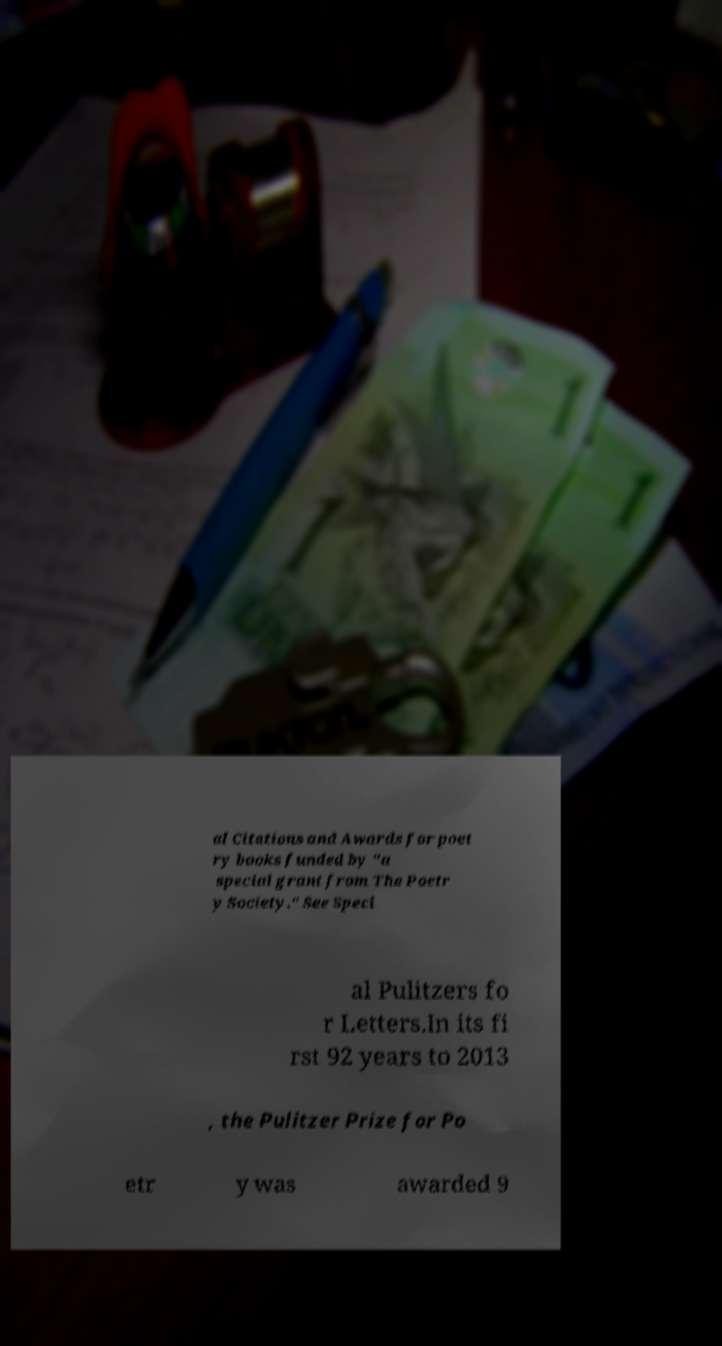Can you read and provide the text displayed in the image?This photo seems to have some interesting text. Can you extract and type it out for me? al Citations and Awards for poet ry books funded by "a special grant from The Poetr y Society." See Speci al Pulitzers fo r Letters.In its fi rst 92 years to 2013 , the Pulitzer Prize for Po etr y was awarded 9 